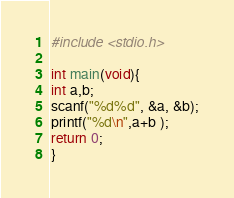Convert code to text. <code><loc_0><loc_0><loc_500><loc_500><_C_>#include <stdio.h>

int main(void){
int a,b;
scanf("%d%d", &a, &b);
printf("%d\n",a+b );
return 0;
}</code> 